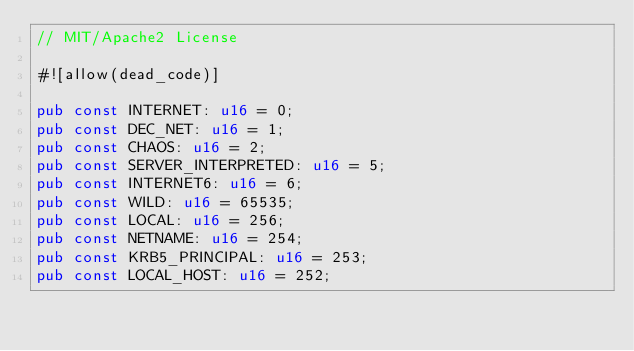<code> <loc_0><loc_0><loc_500><loc_500><_Rust_>// MIT/Apache2 License

#![allow(dead_code)]

pub const INTERNET: u16 = 0;
pub const DEC_NET: u16 = 1;
pub const CHAOS: u16 = 2;
pub const SERVER_INTERPRETED: u16 = 5;
pub const INTERNET6: u16 = 6;
pub const WILD: u16 = 65535;
pub const LOCAL: u16 = 256;
pub const NETNAME: u16 = 254;
pub const KRB5_PRINCIPAL: u16 = 253;
pub const LOCAL_HOST: u16 = 252;
</code> 